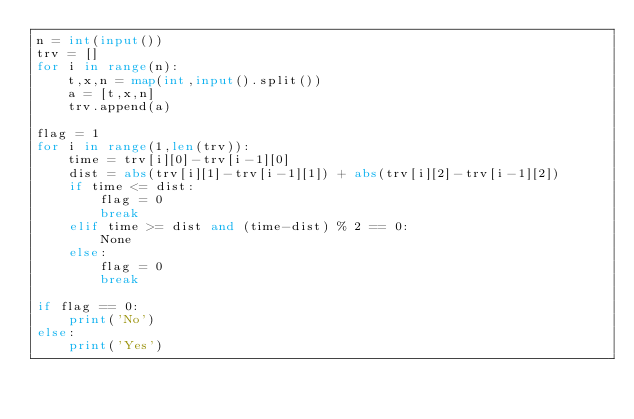<code> <loc_0><loc_0><loc_500><loc_500><_Python_>n = int(input())
trv = []
for i in range(n):
    t,x,n = map(int,input().split())
    a = [t,x,n]
    trv.append(a)

flag = 1
for i in range(1,len(trv)):
    time = trv[i][0]-trv[i-1][0]
    dist = abs(trv[i][1]-trv[i-1][1]) + abs(trv[i][2]-trv[i-1][2])
    if time <= dist:
        flag = 0
        break
    elif time >= dist and (time-dist) % 2 == 0:
        None
    else:
        flag = 0
        break
        
if flag == 0:
    print('No')
else:
    print('Yes')</code> 